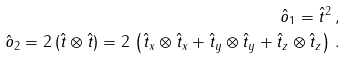<formula> <loc_0><loc_0><loc_500><loc_500>\hat { o } _ { 1 } = \hat { t } ^ { 2 } \, , \\ \hat { o } _ { 2 } = 2 \, ( \hat { t } \otimes \hat { t } ) = 2 \, \left ( \hat { t } _ { x } \otimes \hat { t } _ { x } + \hat { t } _ { y } \otimes \hat { t } _ { y } + \hat { t } _ { z } \otimes \hat { t } _ { z } \right ) \, .</formula> 